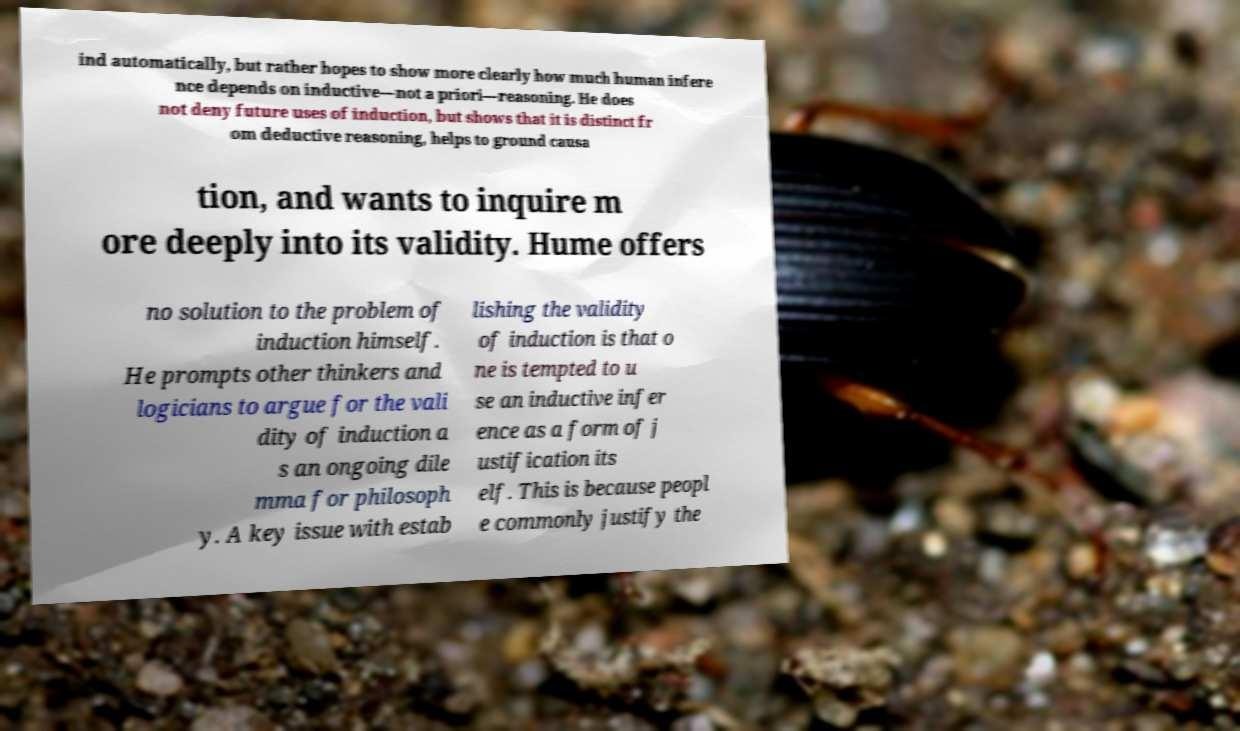Can you read and provide the text displayed in the image?This photo seems to have some interesting text. Can you extract and type it out for me? ind automatically, but rather hopes to show more clearly how much human infere nce depends on inductive—not a priori—reasoning. He does not deny future uses of induction, but shows that it is distinct fr om deductive reasoning, helps to ground causa tion, and wants to inquire m ore deeply into its validity. Hume offers no solution to the problem of induction himself. He prompts other thinkers and logicians to argue for the vali dity of induction a s an ongoing dile mma for philosoph y. A key issue with estab lishing the validity of induction is that o ne is tempted to u se an inductive infer ence as a form of j ustification its elf. This is because peopl e commonly justify the 